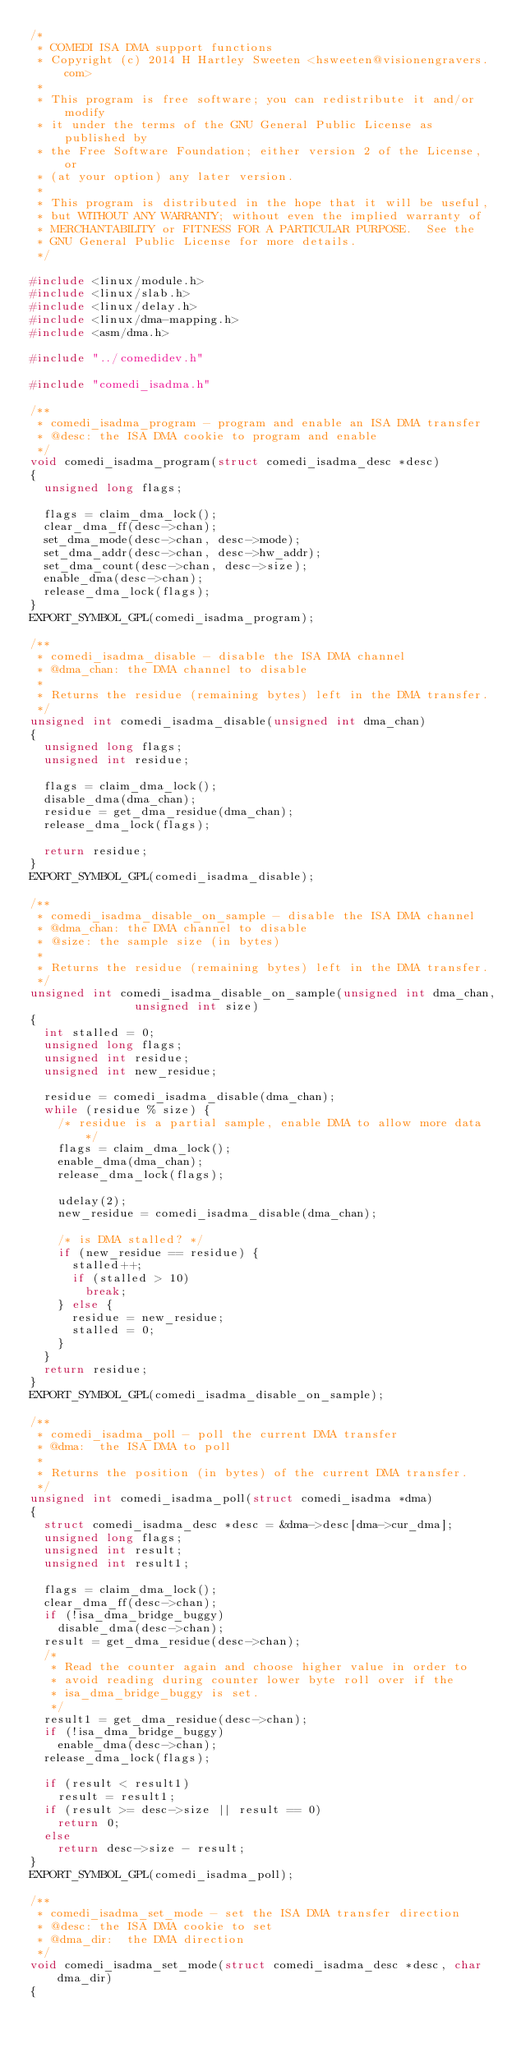Convert code to text. <code><loc_0><loc_0><loc_500><loc_500><_C_>/*
 * COMEDI ISA DMA support functions
 * Copyright (c) 2014 H Hartley Sweeten <hsweeten@visionengravers.com>
 *
 * This program is free software; you can redistribute it and/or modify
 * it under the terms of the GNU General Public License as published by
 * the Free Software Foundation; either version 2 of the License, or
 * (at your option) any later version.
 *
 * This program is distributed in the hope that it will be useful,
 * but WITHOUT ANY WARRANTY; without even the implied warranty of
 * MERCHANTABILITY or FITNESS FOR A PARTICULAR PURPOSE.  See the
 * GNU General Public License for more details.
 */

#include <linux/module.h>
#include <linux/slab.h>
#include <linux/delay.h>
#include <linux/dma-mapping.h>
#include <asm/dma.h>

#include "../comedidev.h"

#include "comedi_isadma.h"

/**
 * comedi_isadma_program - program and enable an ISA DMA transfer
 * @desc:	the ISA DMA cookie to program and enable
 */
void comedi_isadma_program(struct comedi_isadma_desc *desc)
{
	unsigned long flags;

	flags = claim_dma_lock();
	clear_dma_ff(desc->chan);
	set_dma_mode(desc->chan, desc->mode);
	set_dma_addr(desc->chan, desc->hw_addr);
	set_dma_count(desc->chan, desc->size);
	enable_dma(desc->chan);
	release_dma_lock(flags);
}
EXPORT_SYMBOL_GPL(comedi_isadma_program);

/**
 * comedi_isadma_disable - disable the ISA DMA channel
 * @dma_chan:	the DMA channel to disable
 *
 * Returns the residue (remaining bytes) left in the DMA transfer.
 */
unsigned int comedi_isadma_disable(unsigned int dma_chan)
{
	unsigned long flags;
	unsigned int residue;

	flags = claim_dma_lock();
	disable_dma(dma_chan);
	residue = get_dma_residue(dma_chan);
	release_dma_lock(flags);

	return residue;
}
EXPORT_SYMBOL_GPL(comedi_isadma_disable);

/**
 * comedi_isadma_disable_on_sample - disable the ISA DMA channel
 * @dma_chan:	the DMA channel to disable
 * @size:	the sample size (in bytes)
 *
 * Returns the residue (remaining bytes) left in the DMA transfer.
 */
unsigned int comedi_isadma_disable_on_sample(unsigned int dma_chan,
					     unsigned int size)
{
	int stalled = 0;
	unsigned long flags;
	unsigned int residue;
	unsigned int new_residue;

	residue = comedi_isadma_disable(dma_chan);
	while (residue % size) {
		/* residue is a partial sample, enable DMA to allow more data */
		flags = claim_dma_lock();
		enable_dma(dma_chan);
		release_dma_lock(flags);

		udelay(2);
		new_residue = comedi_isadma_disable(dma_chan);

		/* is DMA stalled? */
		if (new_residue == residue) {
			stalled++;
			if (stalled > 10)
				break;
		} else {
			residue = new_residue;
			stalled = 0;
		}
	}
	return residue;
}
EXPORT_SYMBOL_GPL(comedi_isadma_disable_on_sample);

/**
 * comedi_isadma_poll - poll the current DMA transfer
 * @dma:	the ISA DMA to poll
 *
 * Returns the position (in bytes) of the current DMA transfer.
 */
unsigned int comedi_isadma_poll(struct comedi_isadma *dma)
{
	struct comedi_isadma_desc *desc = &dma->desc[dma->cur_dma];
	unsigned long flags;
	unsigned int result;
	unsigned int result1;

	flags = claim_dma_lock();
	clear_dma_ff(desc->chan);
	if (!isa_dma_bridge_buggy)
		disable_dma(desc->chan);
	result = get_dma_residue(desc->chan);
	/*
	 * Read the counter again and choose higher value in order to
	 * avoid reading during counter lower byte roll over if the
	 * isa_dma_bridge_buggy is set.
	 */
	result1 = get_dma_residue(desc->chan);
	if (!isa_dma_bridge_buggy)
		enable_dma(desc->chan);
	release_dma_lock(flags);

	if (result < result1)
		result = result1;
	if (result >= desc->size || result == 0)
		return 0;
	else
		return desc->size - result;
}
EXPORT_SYMBOL_GPL(comedi_isadma_poll);

/**
 * comedi_isadma_set_mode - set the ISA DMA transfer direction
 * @desc:	the ISA DMA cookie to set
 * @dma_dir:	the DMA direction
 */
void comedi_isadma_set_mode(struct comedi_isadma_desc *desc, char dma_dir)
{</code> 